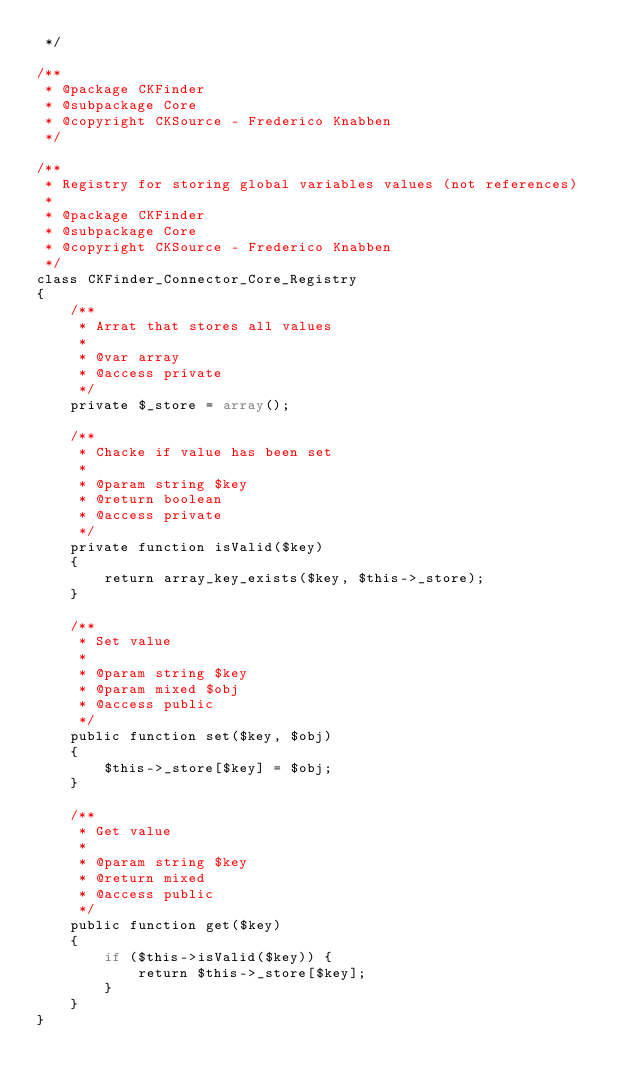<code> <loc_0><loc_0><loc_500><loc_500><_PHP_> */

/**
 * @package CKFinder
 * @subpackage Core
 * @copyright CKSource - Frederico Knabben
 */

/**
 * Registry for storing global variables values (not references)
 *
 * @package CKFinder
 * @subpackage Core
 * @copyright CKSource - Frederico Knabben
 */
class CKFinder_Connector_Core_Registry
{
    /**
     * Arrat that stores all values
     *
     * @var array
     * @access private
     */
    private $_store = array();

    /**
     * Chacke if value has been set
     *
     * @param string $key
     * @return boolean
     * @access private
     */
    private function isValid($key)
    {
        return array_key_exists($key, $this->_store);
    }

    /**
     * Set value
     *
     * @param string $key
     * @param mixed $obj
     * @access public
     */
    public function set($key, $obj)
    {
        $this->_store[$key] = $obj;
    }

    /**
     * Get value
     *
     * @param string $key
     * @return mixed
     * @access public
     */
    public function get($key)
    {
    	if ($this->isValid($key)) {
    	    return $this->_store[$key];
    	}
    }
}
</code> 